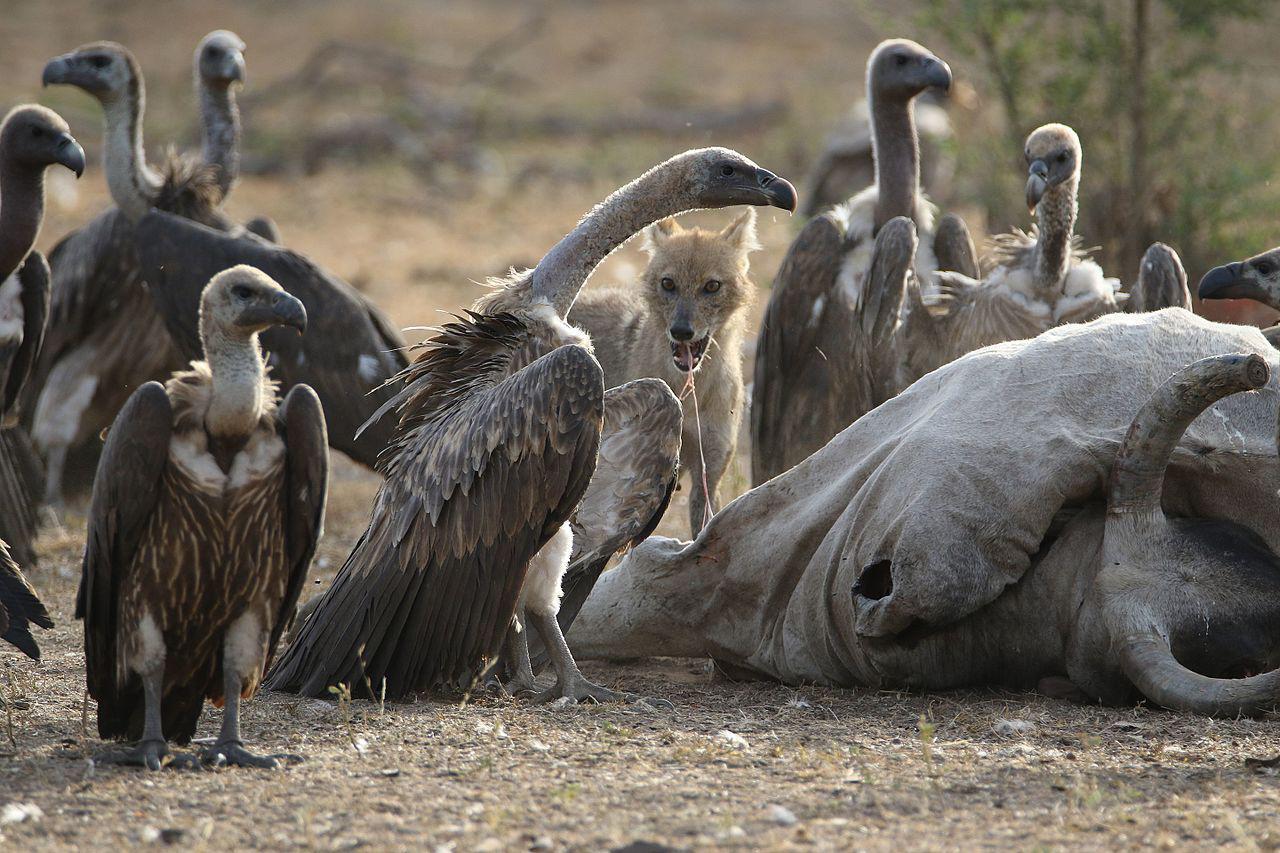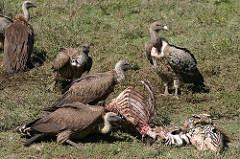The first image is the image on the left, the second image is the image on the right. For the images displayed, is the sentence "An image shows multiple brown vultures around a ribcage." factually correct? Answer yes or no. Yes. The first image is the image on the left, the second image is the image on the right. Considering the images on both sides, is "One of the images shows the bones from the rib cage of a dead animal." valid? Answer yes or no. Yes. 